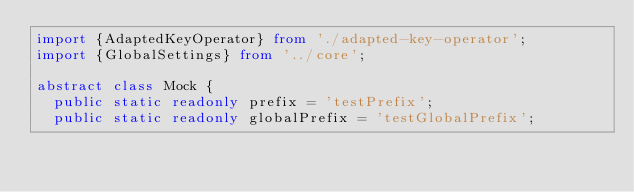<code> <loc_0><loc_0><loc_500><loc_500><_TypeScript_>import {AdaptedKeyOperator} from './adapted-key-operator';
import {GlobalSettings} from '../core';

abstract class Mock {
  public static readonly prefix = 'testPrefix';
  public static readonly globalPrefix = 'testGlobalPrefix';</code> 